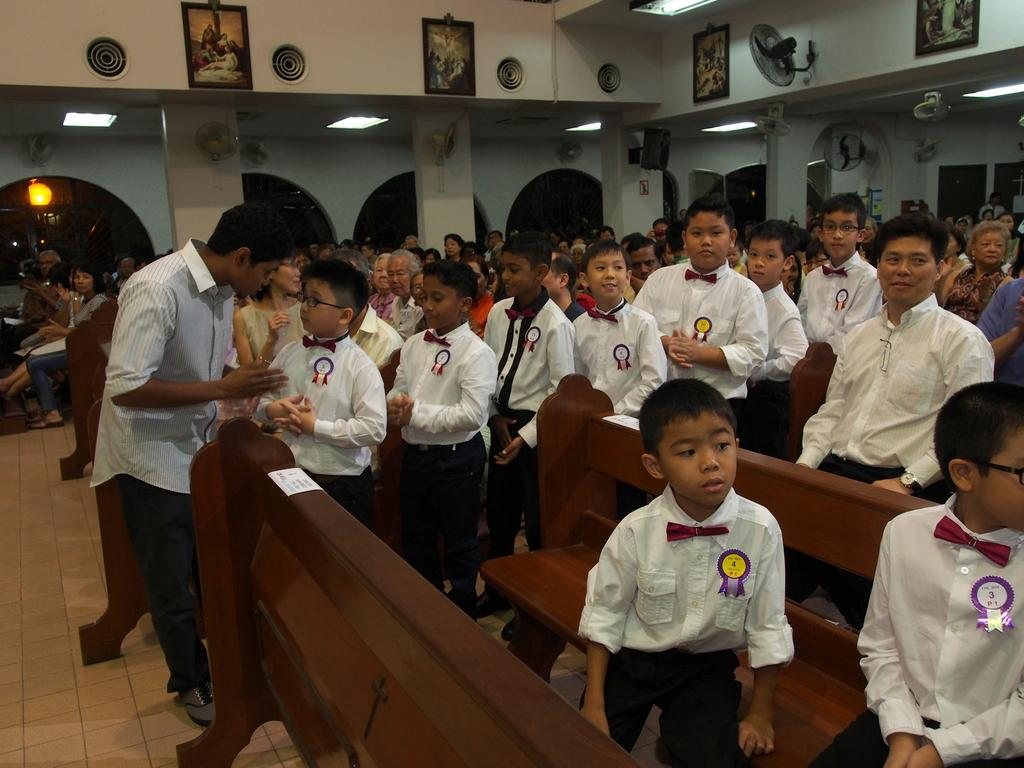Who is present in the image? There are kids in the image. What are the people in the image doing? There are people sitting on benches in the image. What can be seen illuminating the scene in the image? There are lights in the image. What type of decorative elements are on the walls in the image? There are frames on the walls in the image. What type of stone can be seen at the seashore in the image? There is no seashore or stone present in the image. 